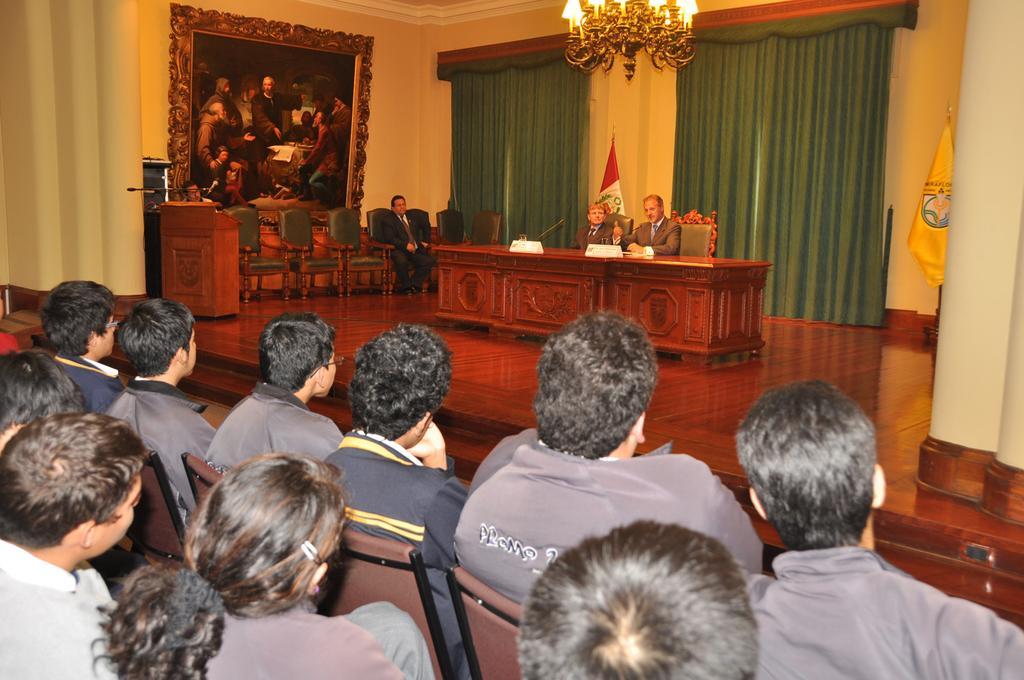In one or two sentences, can you explain what this image depicts? In this picture we can see two persons sitting on chair and in front of them we have table and back of them there is a glass and here on left side person is sitting and here is the podium and we have wall a big frame on it , curtains, light and below this stage we have a group of people looking at them. 